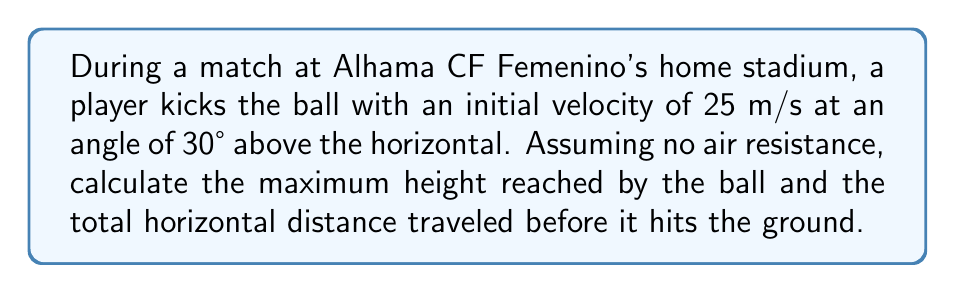Give your solution to this math problem. Let's approach this problem step-by-step using the equations of projectile motion:

1) First, we need to decompose the initial velocity into its horizontal and vertical components:

   $v_{0x} = v_0 \cos \theta = 25 \cos 30° = 21.65$ m/s
   $v_{0y} = v_0 \sin \theta = 25 \sin 30° = 12.5$ m/s

2) To find the maximum height, we use the equation:

   $h_{max} = \frac{v_{0y}^2}{2g}$

   Where $g$ is the acceleration due to gravity (9.8 m/s²).

   $h_{max} = \frac{(12.5)^2}{2(9.8)} = 7.97$ m

3) To find the total horizontal distance (range), we need to calculate the time of flight first. The time to reach the maximum height is:

   $t_{up} = \frac{v_{0y}}{g} = \frac{12.5}{9.8} = 1.28$ s

   The total time of flight is twice this value:

   $t_{total} = 2t_{up} = 2(1.28) = 2.56$ s

4) Now we can calculate the range using:

   $R = v_{0x} \cdot t_{total} = 21.65 \cdot 2.56 = 55.42$ m

Therefore, the ball reaches a maximum height of 7.97 m and travels a horizontal distance of 55.42 m.
Answer: Maximum height: 7.97 m; Horizontal distance: 55.42 m 